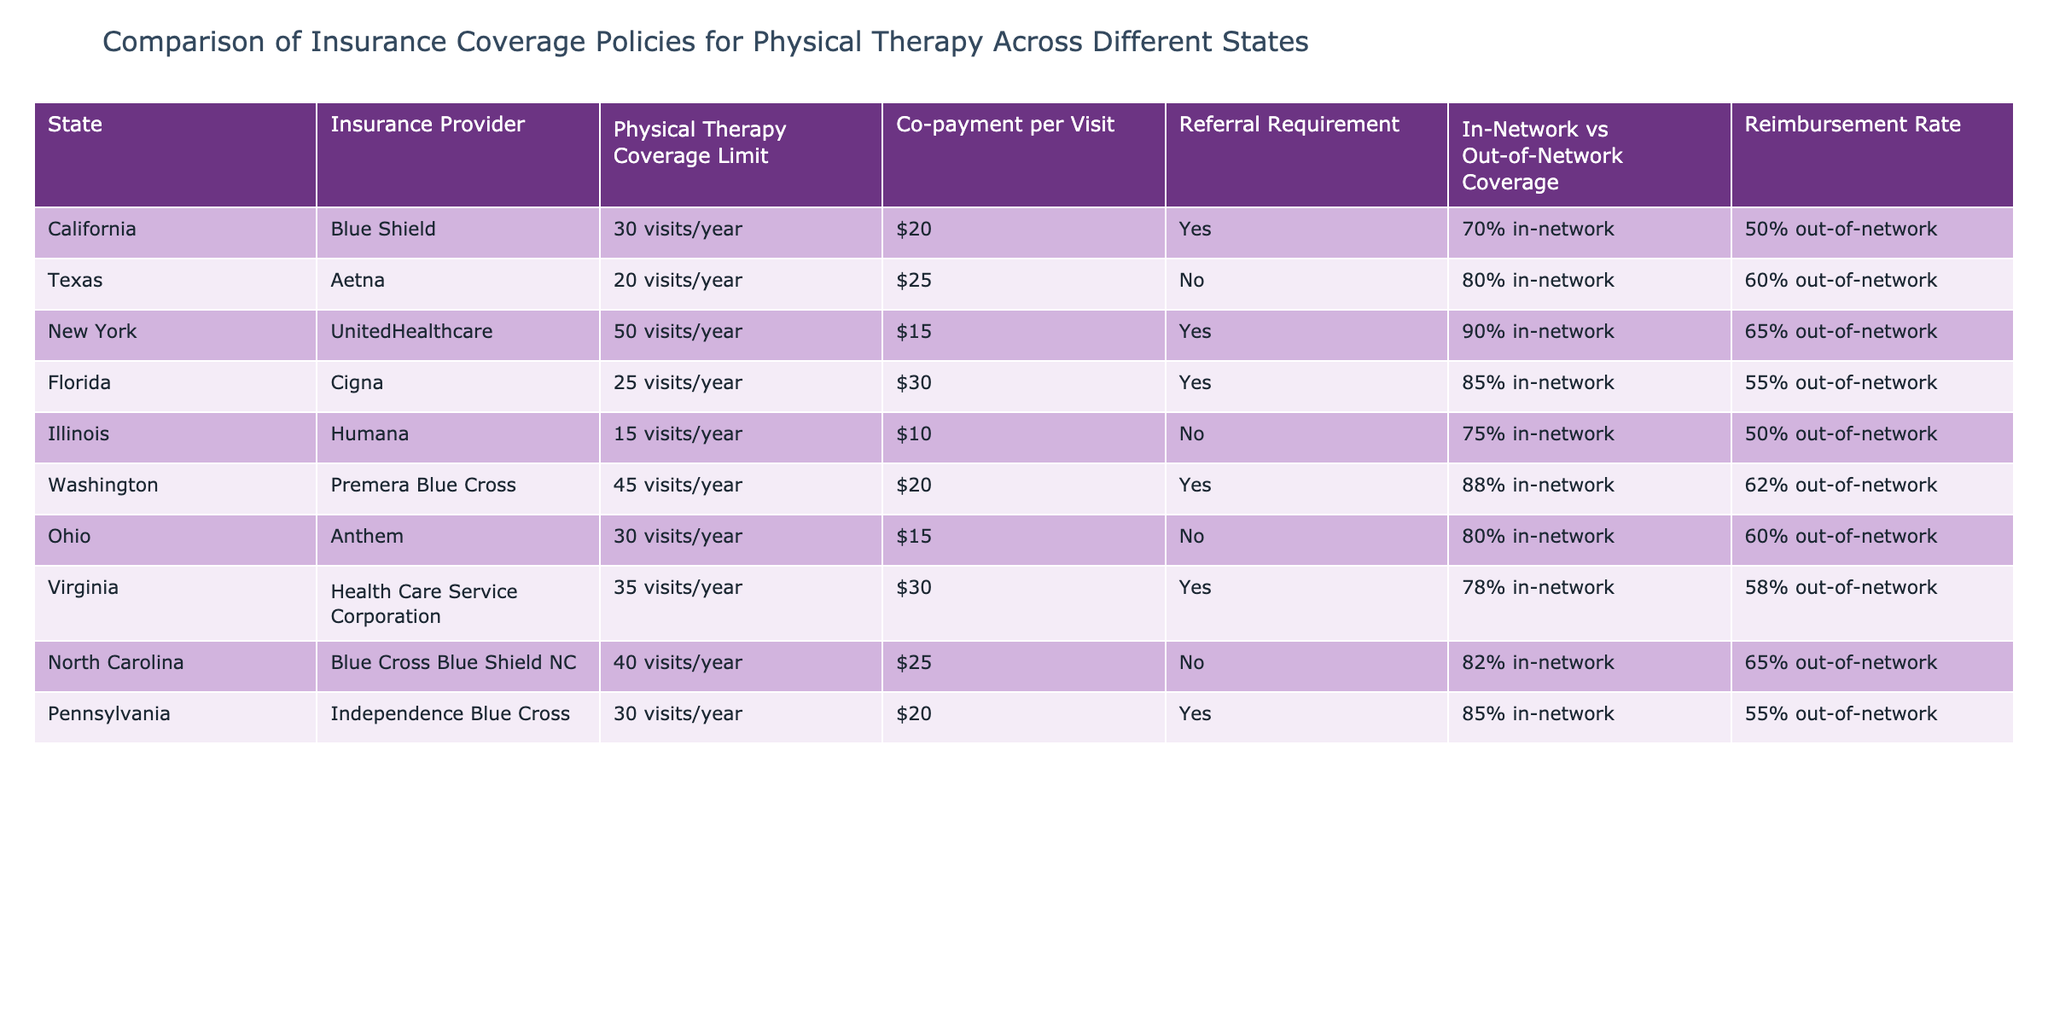What is the physical therapy coverage limit in New York? In the table, under the row for New York, the physical therapy coverage limit is explicitly listed as 50 visits/year.
Answer: 50 visits/year Which state has the highest co-payment per visit for physical therapy? By comparing the co-payment amounts across all states listed in the table, Florida has the highest co-payment per visit at $30.
Answer: Florida Is a referral required for physical therapy coverage in Illinois? In the table, under the row for Illinois, it states "No" for the referral requirement, indicating that a referral is not necessary for physical therapy coverage in this state.
Answer: No How many total physical therapy visits are covered in Texas and Illinois combined? The physical therapy coverage limits for Texas and Illinois are 20 visits/year and 15 visits/year, respectively. Therefore, the total combined is 20 + 15 = 35 visits/year.
Answer: 35 visits/year What percentage of in-network coverage does Blue Shield in California offer? The table shows that Blue Shield in California offers 70% in-network coverage for physical therapy services.
Answer: 70% Which state allows the most physical therapy visits and does not require a referral? After examining the states that do not require referrals (Texas, Illinois, Ohio, & North Carolina), the highest coverage limit belongs to North Carolina at 40 visits/year, which is more than the limits of the other states identified.
Answer: North Carolina Is Virginia's out-of-network reimbursement rate higher than Illinois's? The out-of-network reimbursement rate for Virginia is 58%, while for Illinois, it is 50%. Thus, Virginia's rate is indeed higher than Illinois's.
Answer: Yes What is the average co-payment per visit for all states listed? The co-payments to consider are $20, $25, $15, $30, $10, $20, $15, $30, $25, $20. Summing these gives $20 + $25 + $15 + $30 + $10 + $20 + $15 + $30 + $25 + $20 = $ 205. Dividing by 10 gives an average co-payment of 205/10 = $20.50.
Answer: $20.50 How many states have a physical therapy coverage limit greater than 30 visits/year? By reviewing the table, the states with coverage limits greater than 30 are New York (50), Washington (45), and North Carolina (40), which totals three states.
Answer: 3 